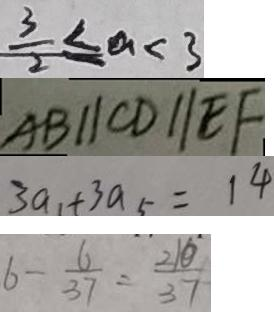<formula> <loc_0><loc_0><loc_500><loc_500>\frac { 3 } { 2 } \leq a < 3 
 A B / / C D / / E F 
 3 a _ { 1 } + 3 a _ { 5 } = 1 4 
 6 - \frac { 6 } { 3 7 } = \frac { 2 1 0 } { 3 7 }</formula> 